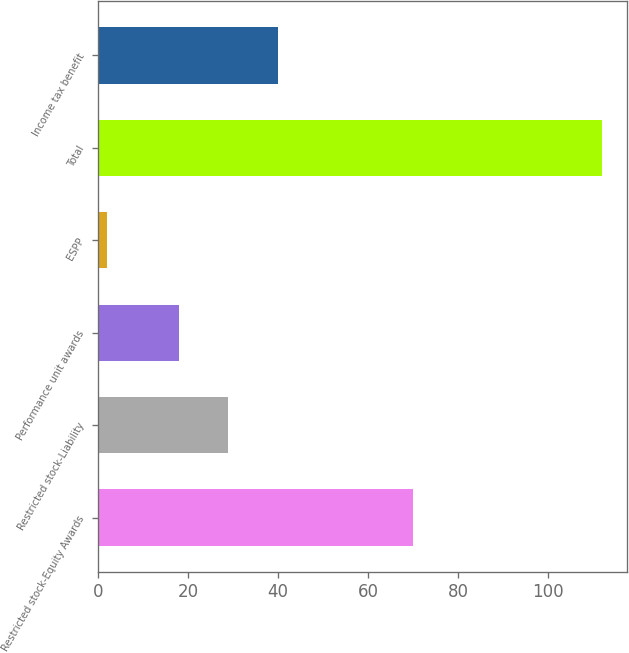<chart> <loc_0><loc_0><loc_500><loc_500><bar_chart><fcel>Restricted stock-Equity Awards<fcel>Restricted stock-Liability<fcel>Performance unit awards<fcel>ESPP<fcel>Total<fcel>Income tax benefit<nl><fcel>70<fcel>29<fcel>18<fcel>2<fcel>112<fcel>40<nl></chart> 